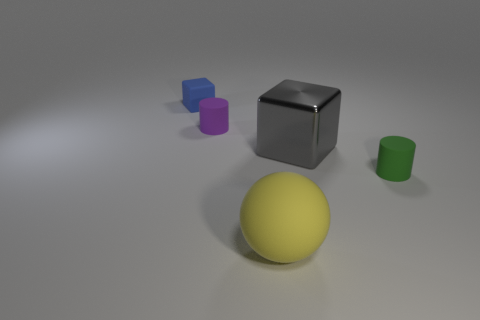Subtract all green cylinders. How many cylinders are left? 1 Subtract all big metallic blocks. Subtract all small matte things. How many objects are left? 1 Add 4 cylinders. How many cylinders are left? 6 Add 5 purple matte cylinders. How many purple matte cylinders exist? 6 Add 1 big yellow rubber balls. How many objects exist? 6 Subtract 0 red cylinders. How many objects are left? 5 Subtract all spheres. How many objects are left? 4 Subtract 2 blocks. How many blocks are left? 0 Subtract all yellow cylinders. Subtract all cyan blocks. How many cylinders are left? 2 Subtract all blue cylinders. How many yellow blocks are left? 0 